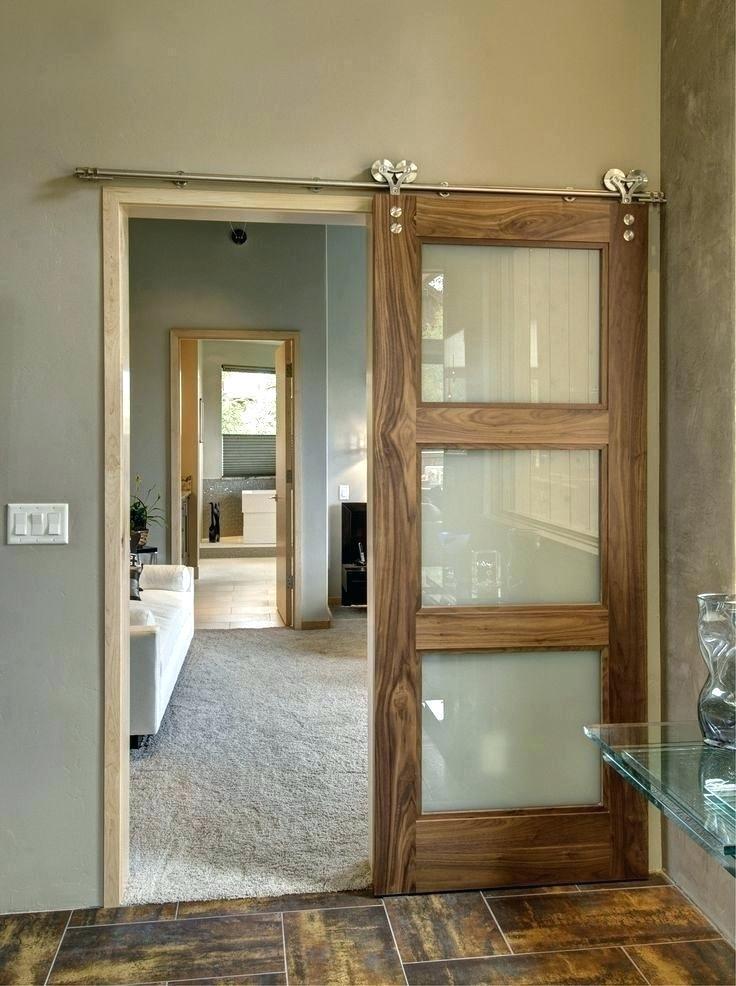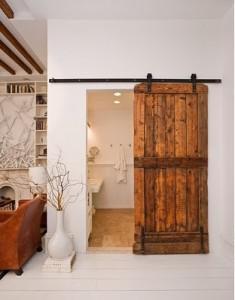The first image is the image on the left, the second image is the image on the right. Considering the images on both sides, is "THere is a total of two hanging doors." valid? Answer yes or no. Yes. The first image is the image on the left, the second image is the image on the right. Analyze the images presented: Is the assertion "One door is open in the center, the other is open to the side." valid? Answer yes or no. No. 